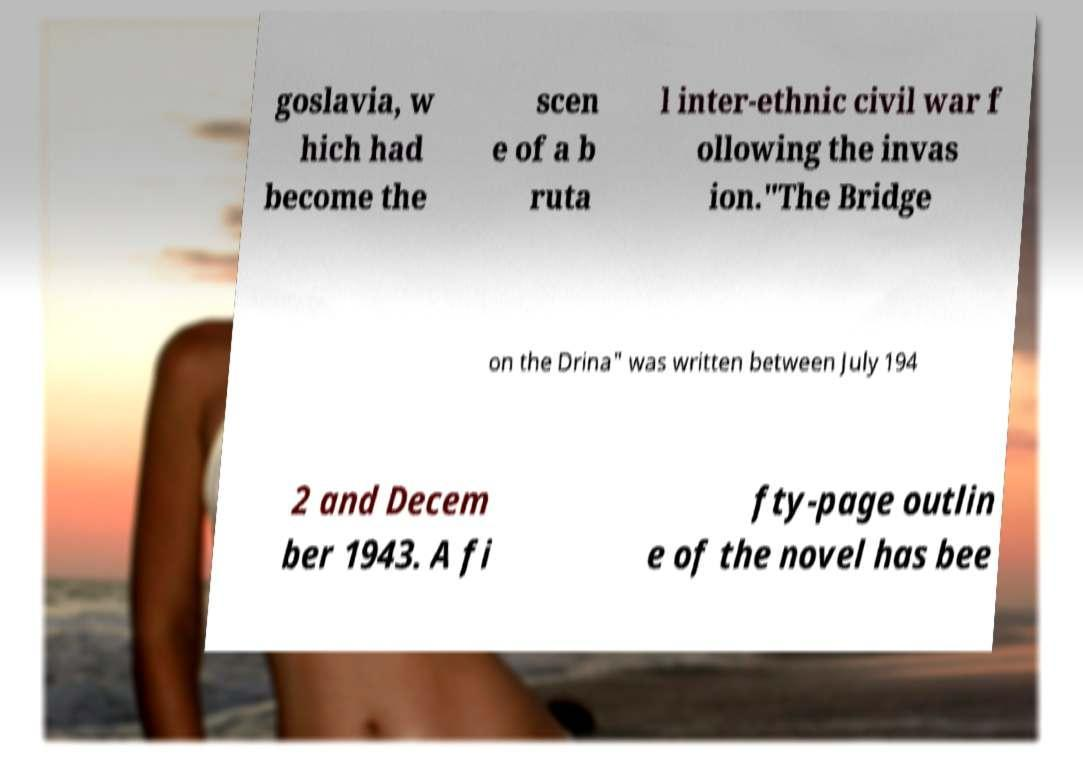Please identify and transcribe the text found in this image. goslavia, w hich had become the scen e of a b ruta l inter-ethnic civil war f ollowing the invas ion."The Bridge on the Drina" was written between July 194 2 and Decem ber 1943. A fi fty-page outlin e of the novel has bee 